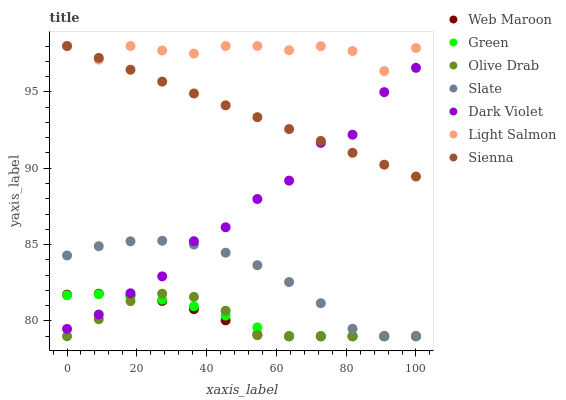Does Olive Drab have the minimum area under the curve?
Answer yes or no. Yes. Does Light Salmon have the maximum area under the curve?
Answer yes or no. Yes. Does Slate have the minimum area under the curve?
Answer yes or no. No. Does Slate have the maximum area under the curve?
Answer yes or no. No. Is Sienna the smoothest?
Answer yes or no. Yes. Is Dark Violet the roughest?
Answer yes or no. Yes. Is Slate the smoothest?
Answer yes or no. No. Is Slate the roughest?
Answer yes or no. No. Does Slate have the lowest value?
Answer yes or no. Yes. Does Dark Violet have the lowest value?
Answer yes or no. No. Does Sienna have the highest value?
Answer yes or no. Yes. Does Slate have the highest value?
Answer yes or no. No. Is Green less than Light Salmon?
Answer yes or no. Yes. Is Sienna greater than Slate?
Answer yes or no. Yes. Does Slate intersect Web Maroon?
Answer yes or no. Yes. Is Slate less than Web Maroon?
Answer yes or no. No. Is Slate greater than Web Maroon?
Answer yes or no. No. Does Green intersect Light Salmon?
Answer yes or no. No. 